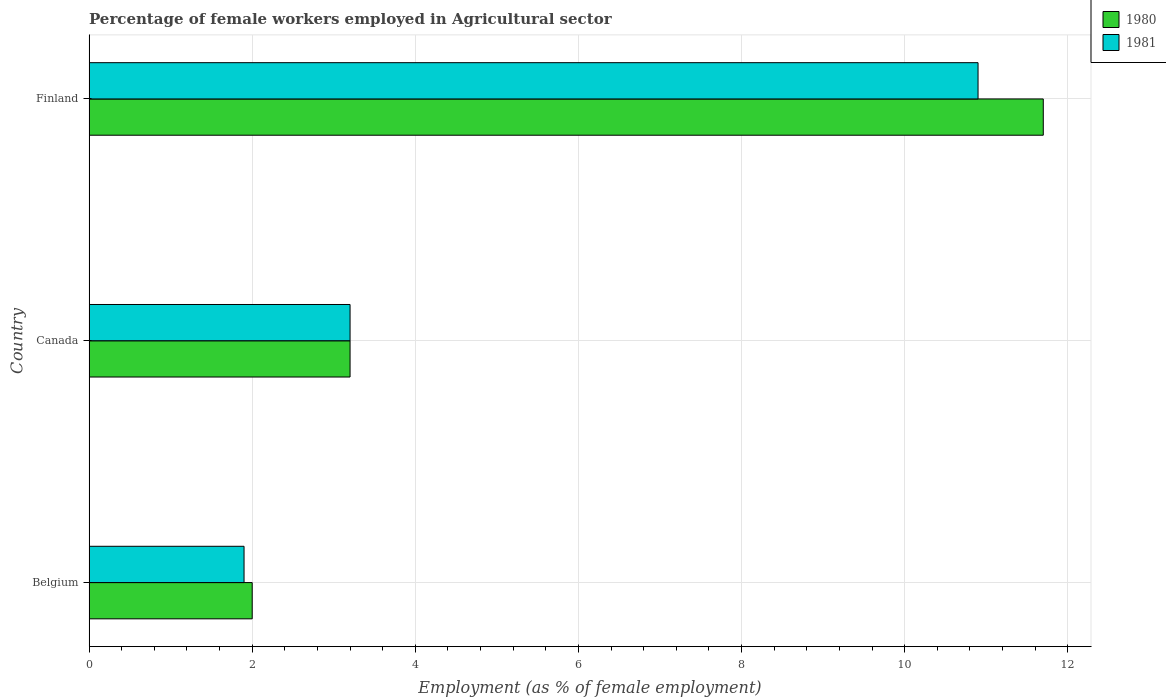How many different coloured bars are there?
Provide a short and direct response. 2. How many groups of bars are there?
Your response must be concise. 3. How many bars are there on the 1st tick from the top?
Give a very brief answer. 2. How many bars are there on the 2nd tick from the bottom?
Provide a short and direct response. 2. What is the percentage of females employed in Agricultural sector in 1981 in Belgium?
Make the answer very short. 1.9. Across all countries, what is the maximum percentage of females employed in Agricultural sector in 1980?
Your response must be concise. 11.7. Across all countries, what is the minimum percentage of females employed in Agricultural sector in 1981?
Give a very brief answer. 1.9. What is the total percentage of females employed in Agricultural sector in 1981 in the graph?
Give a very brief answer. 16. What is the difference between the percentage of females employed in Agricultural sector in 1980 in Belgium and that in Canada?
Your answer should be compact. -1.2. What is the difference between the percentage of females employed in Agricultural sector in 1980 in Belgium and the percentage of females employed in Agricultural sector in 1981 in Finland?
Your answer should be very brief. -8.9. What is the average percentage of females employed in Agricultural sector in 1981 per country?
Your answer should be very brief. 5.33. What is the difference between the percentage of females employed in Agricultural sector in 1980 and percentage of females employed in Agricultural sector in 1981 in Belgium?
Give a very brief answer. 0.1. What is the ratio of the percentage of females employed in Agricultural sector in 1981 in Belgium to that in Finland?
Your response must be concise. 0.17. Is the percentage of females employed in Agricultural sector in 1981 in Belgium less than that in Finland?
Your response must be concise. Yes. What is the difference between the highest and the second highest percentage of females employed in Agricultural sector in 1980?
Make the answer very short. 8.5. What is the difference between the highest and the lowest percentage of females employed in Agricultural sector in 1981?
Offer a very short reply. 9. Is the sum of the percentage of females employed in Agricultural sector in 1981 in Canada and Finland greater than the maximum percentage of females employed in Agricultural sector in 1980 across all countries?
Keep it short and to the point. Yes. How many bars are there?
Your response must be concise. 6. Are all the bars in the graph horizontal?
Your answer should be compact. Yes. What is the difference between two consecutive major ticks on the X-axis?
Your answer should be very brief. 2. Where does the legend appear in the graph?
Make the answer very short. Top right. How many legend labels are there?
Ensure brevity in your answer.  2. How are the legend labels stacked?
Offer a terse response. Vertical. What is the title of the graph?
Offer a very short reply. Percentage of female workers employed in Agricultural sector. Does "2008" appear as one of the legend labels in the graph?
Make the answer very short. No. What is the label or title of the X-axis?
Offer a terse response. Employment (as % of female employment). What is the Employment (as % of female employment) in 1981 in Belgium?
Your answer should be very brief. 1.9. What is the Employment (as % of female employment) of 1980 in Canada?
Give a very brief answer. 3.2. What is the Employment (as % of female employment) in 1981 in Canada?
Your answer should be very brief. 3.2. What is the Employment (as % of female employment) in 1980 in Finland?
Your answer should be compact. 11.7. What is the Employment (as % of female employment) in 1981 in Finland?
Your response must be concise. 10.9. Across all countries, what is the maximum Employment (as % of female employment) of 1980?
Your answer should be very brief. 11.7. Across all countries, what is the maximum Employment (as % of female employment) in 1981?
Ensure brevity in your answer.  10.9. Across all countries, what is the minimum Employment (as % of female employment) of 1981?
Make the answer very short. 1.9. What is the total Employment (as % of female employment) of 1980 in the graph?
Give a very brief answer. 16.9. What is the difference between the Employment (as % of female employment) of 1980 in Belgium and that in Canada?
Provide a short and direct response. -1.2. What is the difference between the Employment (as % of female employment) of 1981 in Belgium and that in Canada?
Offer a terse response. -1.3. What is the difference between the Employment (as % of female employment) of 1980 in Belgium and that in Finland?
Keep it short and to the point. -9.7. What is the average Employment (as % of female employment) in 1980 per country?
Offer a terse response. 5.63. What is the average Employment (as % of female employment) of 1981 per country?
Ensure brevity in your answer.  5.33. What is the difference between the Employment (as % of female employment) of 1980 and Employment (as % of female employment) of 1981 in Belgium?
Offer a terse response. 0.1. What is the difference between the Employment (as % of female employment) of 1980 and Employment (as % of female employment) of 1981 in Canada?
Offer a very short reply. 0. What is the difference between the Employment (as % of female employment) in 1980 and Employment (as % of female employment) in 1981 in Finland?
Give a very brief answer. 0.8. What is the ratio of the Employment (as % of female employment) in 1980 in Belgium to that in Canada?
Offer a very short reply. 0.62. What is the ratio of the Employment (as % of female employment) in 1981 in Belgium to that in Canada?
Ensure brevity in your answer.  0.59. What is the ratio of the Employment (as % of female employment) in 1980 in Belgium to that in Finland?
Your answer should be very brief. 0.17. What is the ratio of the Employment (as % of female employment) in 1981 in Belgium to that in Finland?
Your answer should be very brief. 0.17. What is the ratio of the Employment (as % of female employment) of 1980 in Canada to that in Finland?
Your response must be concise. 0.27. What is the ratio of the Employment (as % of female employment) of 1981 in Canada to that in Finland?
Give a very brief answer. 0.29. What is the difference between the highest and the lowest Employment (as % of female employment) of 1980?
Give a very brief answer. 9.7. 